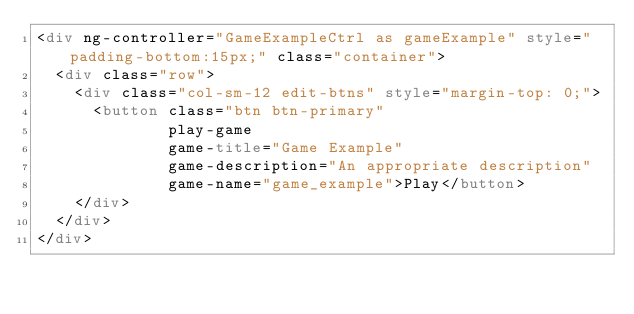<code> <loc_0><loc_0><loc_500><loc_500><_HTML_><div ng-controller="GameExampleCtrl as gameExample" style="padding-bottom:15px;" class="container">
  <div class="row">
    <div class="col-sm-12 edit-btns" style="margin-top: 0;">
      <button class="btn btn-primary"
              play-game
              game-title="Game Example"
              game-description="An appropriate description"
              game-name="game_example">Play</button>
    </div>
  </div>
</div></code> 